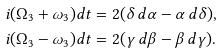Convert formula to latex. <formula><loc_0><loc_0><loc_500><loc_500>i ( \Omega _ { 3 } + \omega _ { 3 } ) d t & = 2 ( \delta \, d \alpha - \alpha \, d \delta ) , \\ i ( \Omega _ { 3 } - \omega _ { 3 } ) d t & = 2 ( \gamma \, d \beta - \beta \, d \gamma ) .</formula> 